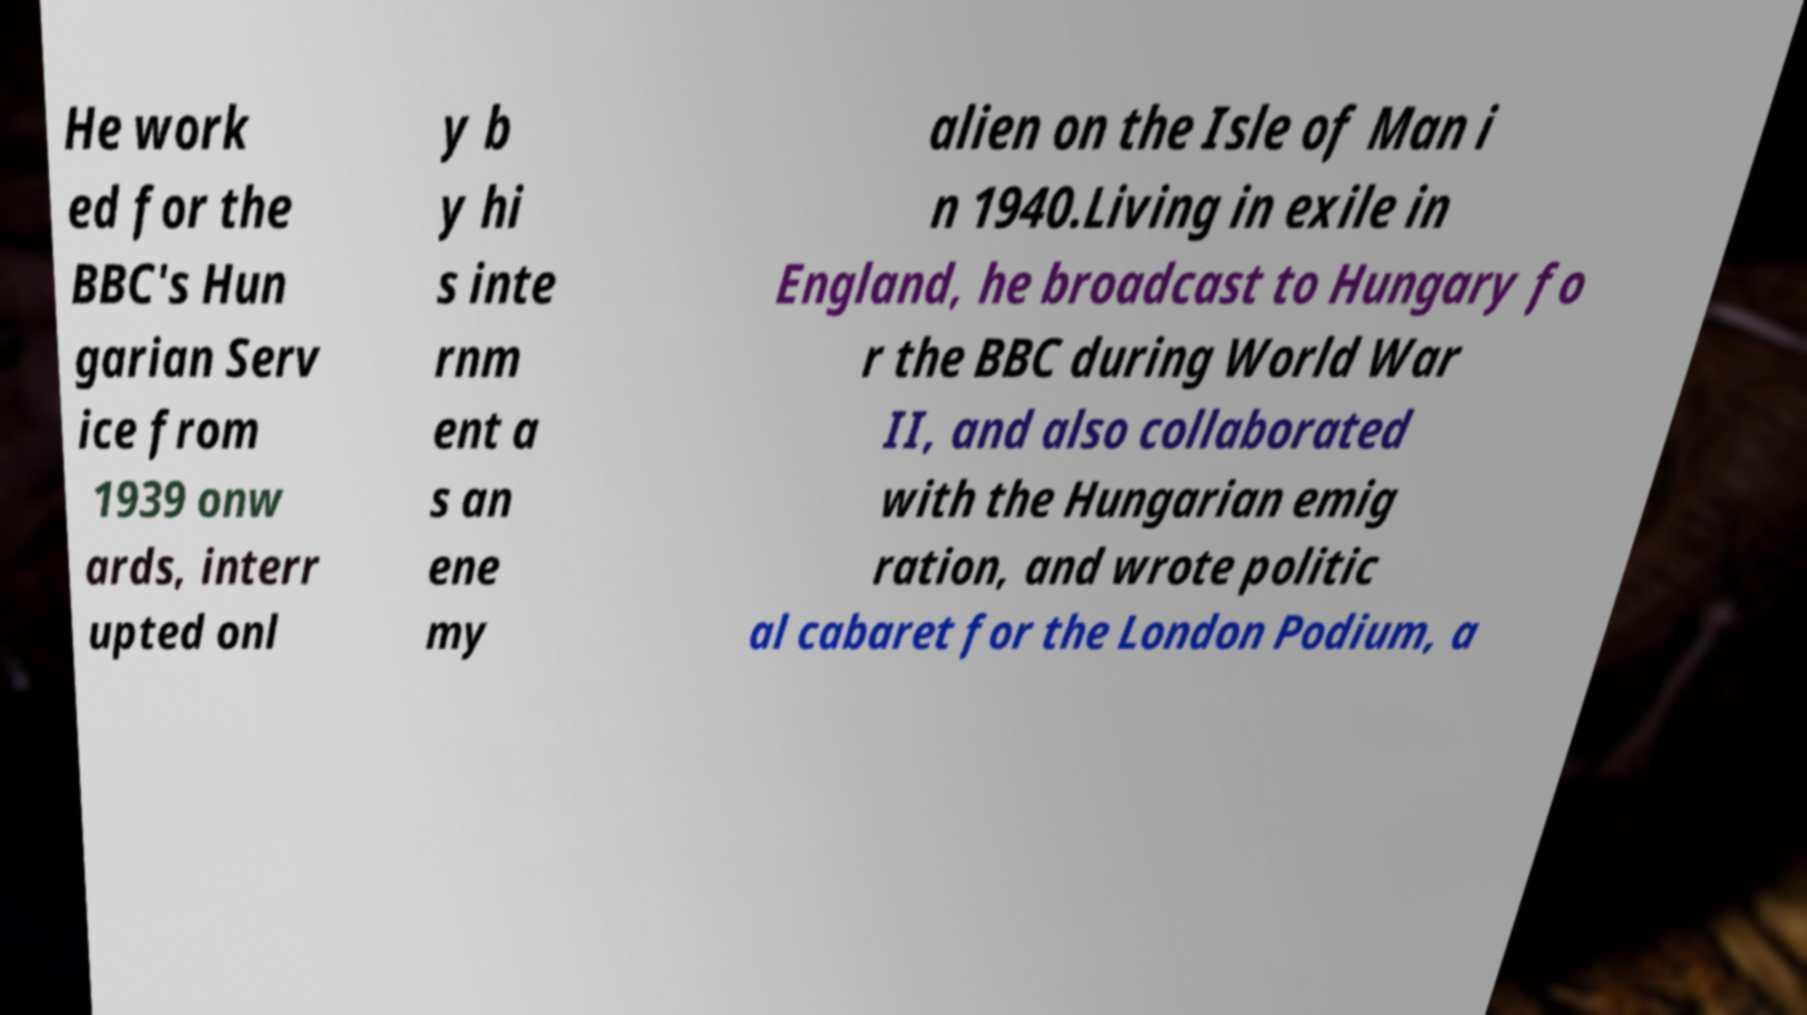Could you extract and type out the text from this image? He work ed for the BBC's Hun garian Serv ice from 1939 onw ards, interr upted onl y b y hi s inte rnm ent a s an ene my alien on the Isle of Man i n 1940.Living in exile in England, he broadcast to Hungary fo r the BBC during World War II, and also collaborated with the Hungarian emig ration, and wrote politic al cabaret for the London Podium, a 